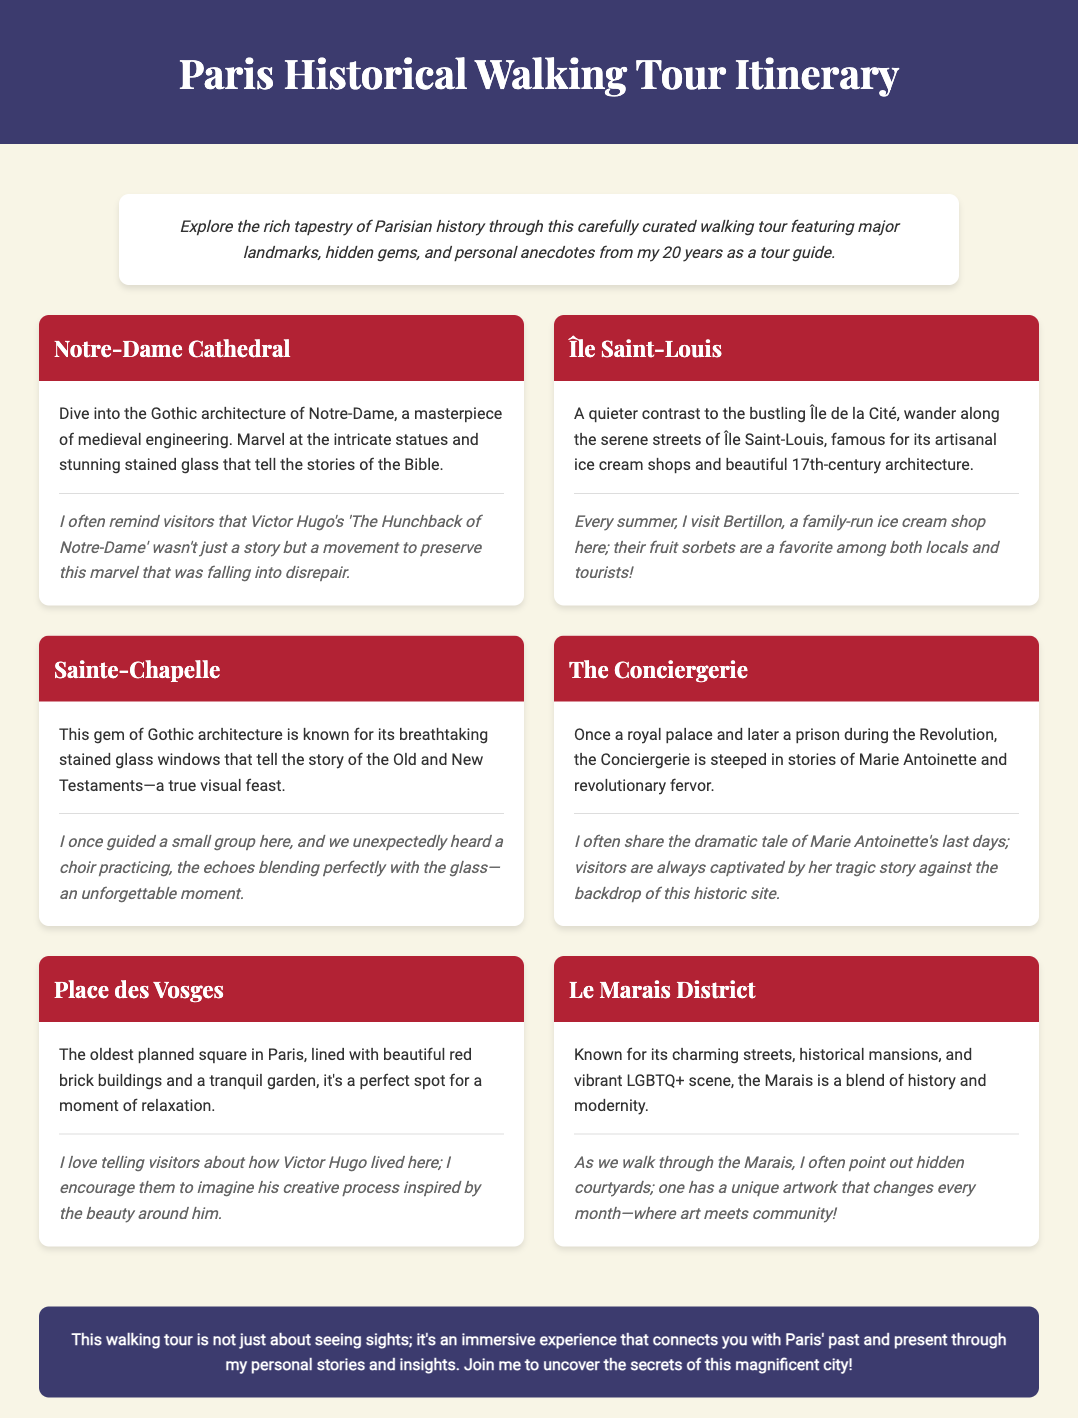What is the name of the first landmark on the tour? The first landmark listed in the document is Notre-Dame Cathedral.
Answer: Notre-Dame Cathedral How many anecdotes are provided in the document? There are six anecdotes accompanying each landmark description, one for each.
Answer: Six What significant author is associated with the Notre-Dame Cathedral? The document mentions Victor Hugo in relation to the Notre-Dame Cathedral's preservation.
Answer: Victor Hugo Which ice cream shop is mentioned in relation to Île Saint-Louis? The document refers to Bertillon as a well-known ice cream shop on Île Saint-Louis.
Answer: Bertillon What is the oldest planned square in Paris? The document states that Place des Vosges is the oldest planned square in Paris.
Answer: Place des Vosges Which district is known for its vibrant LGBTQ+ scene? The document indicates that the Le Marais District is known for its lively LGBTQ+ community.
Answer: Le Marais District What architectural style is Sainte-Chapelle known for? The document identifies the architectural style of Sainte-Chapelle as Gothic architecture.
Answer: Gothic architecture What historical event is associated with The Conciergerie? The Conciergerie is connected to the events surrounding the French Revolution.
Answer: French Revolution 